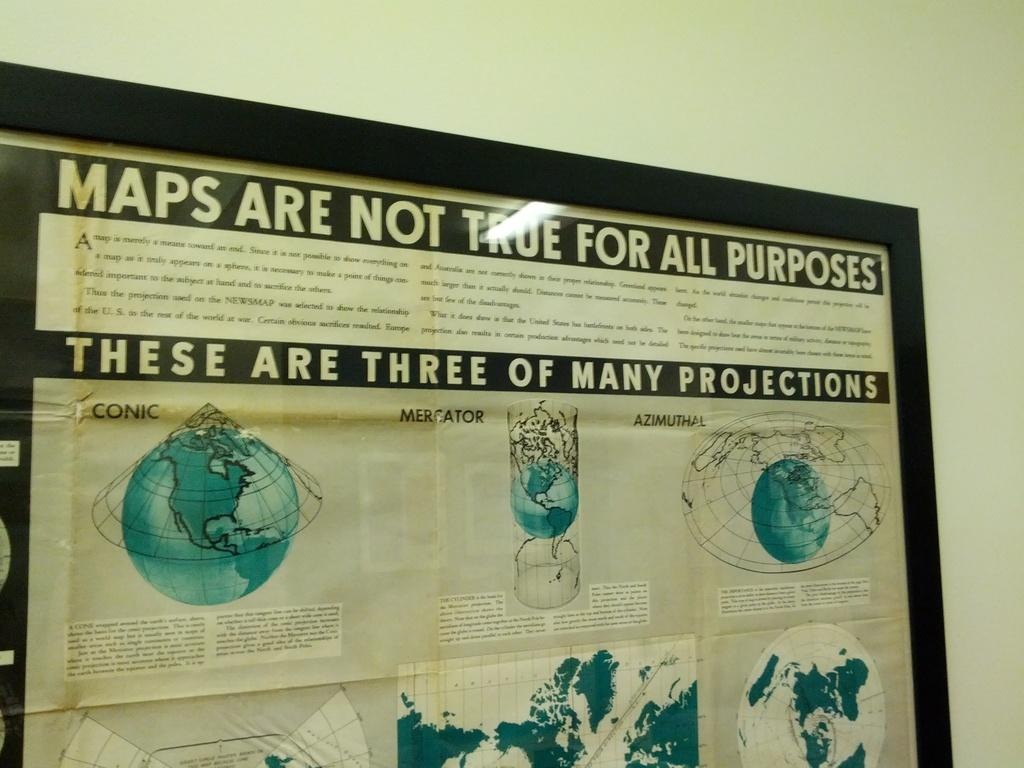<image>
Render a clear and concise summary of the photo. A large poster is in a frame that shows a globe and says Maps Are Not True For All Purposes. 